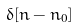<formula> <loc_0><loc_0><loc_500><loc_500>\delta [ n - n _ { 0 } ]</formula> 